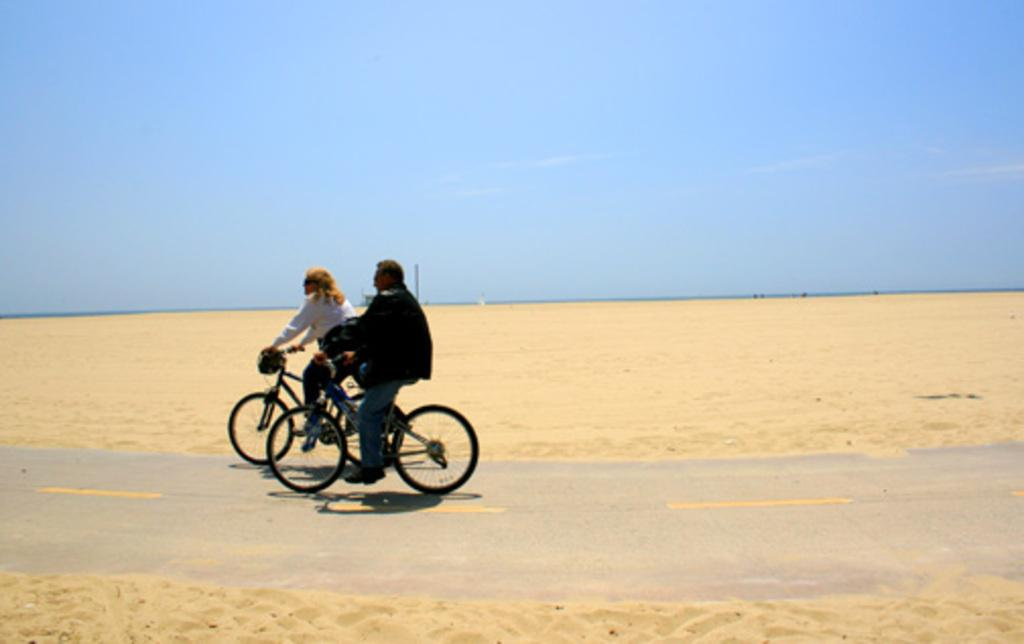How many people are in the image? There are two persons in the image. What are the persons doing in the image? The persons are riding bicycles. What can be seen in the background of the image? There is a pole and sand in the background of the image. What is the color of the sky in the image? The sky is blue in color. What type of organization is responsible for the selection of cows in the image? There are no cows present in the image, and therefore no organization or selection process is relevant to the image. 